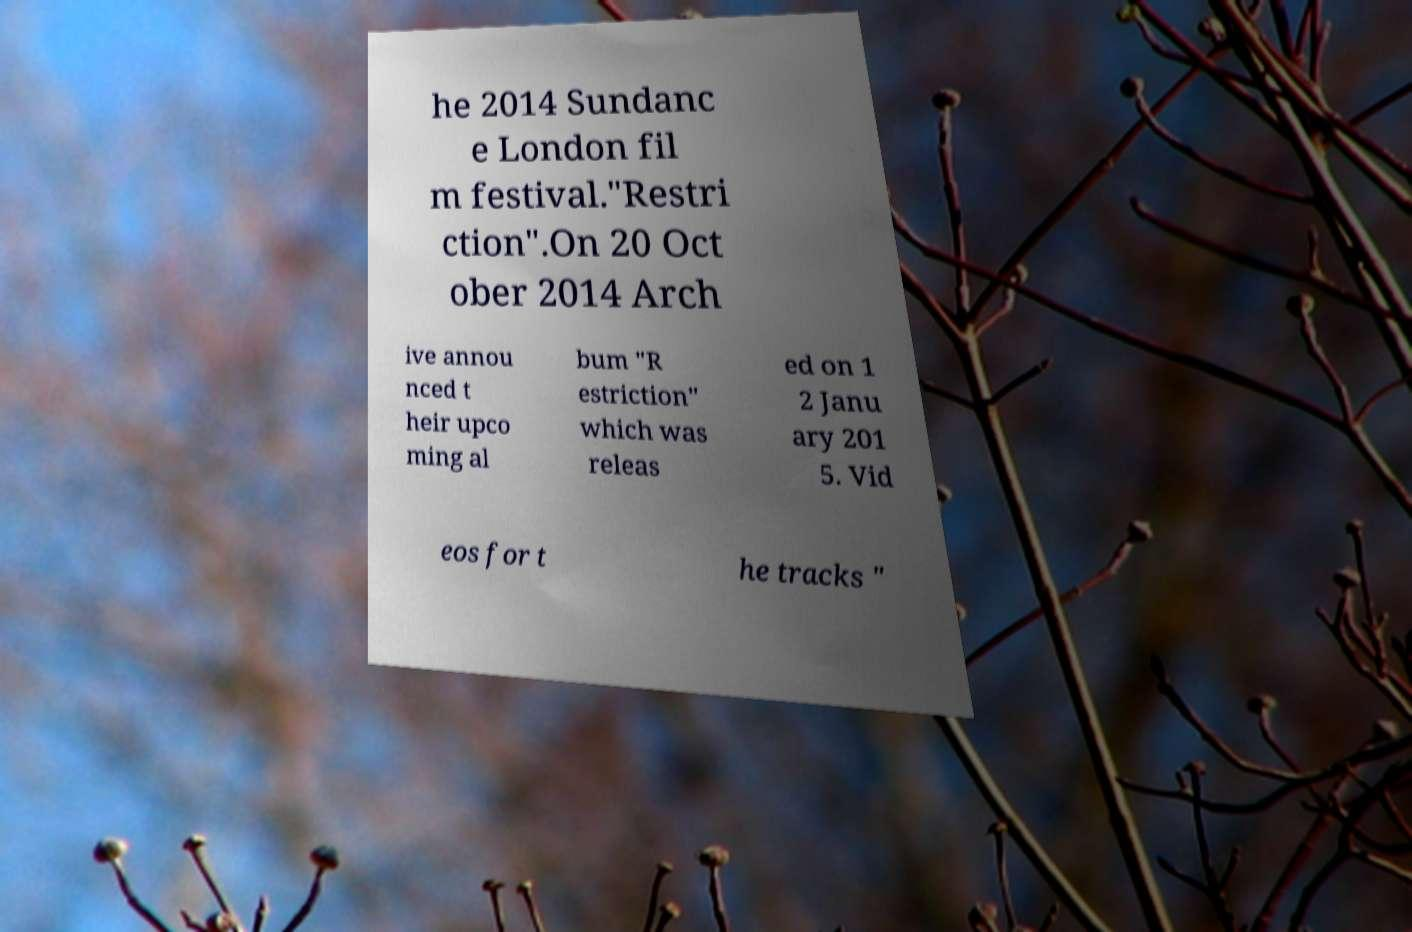There's text embedded in this image that I need extracted. Can you transcribe it verbatim? he 2014 Sundanc e London fil m festival."Restri ction".On 20 Oct ober 2014 Arch ive annou nced t heir upco ming al bum "R estriction" which was releas ed on 1 2 Janu ary 201 5. Vid eos for t he tracks " 